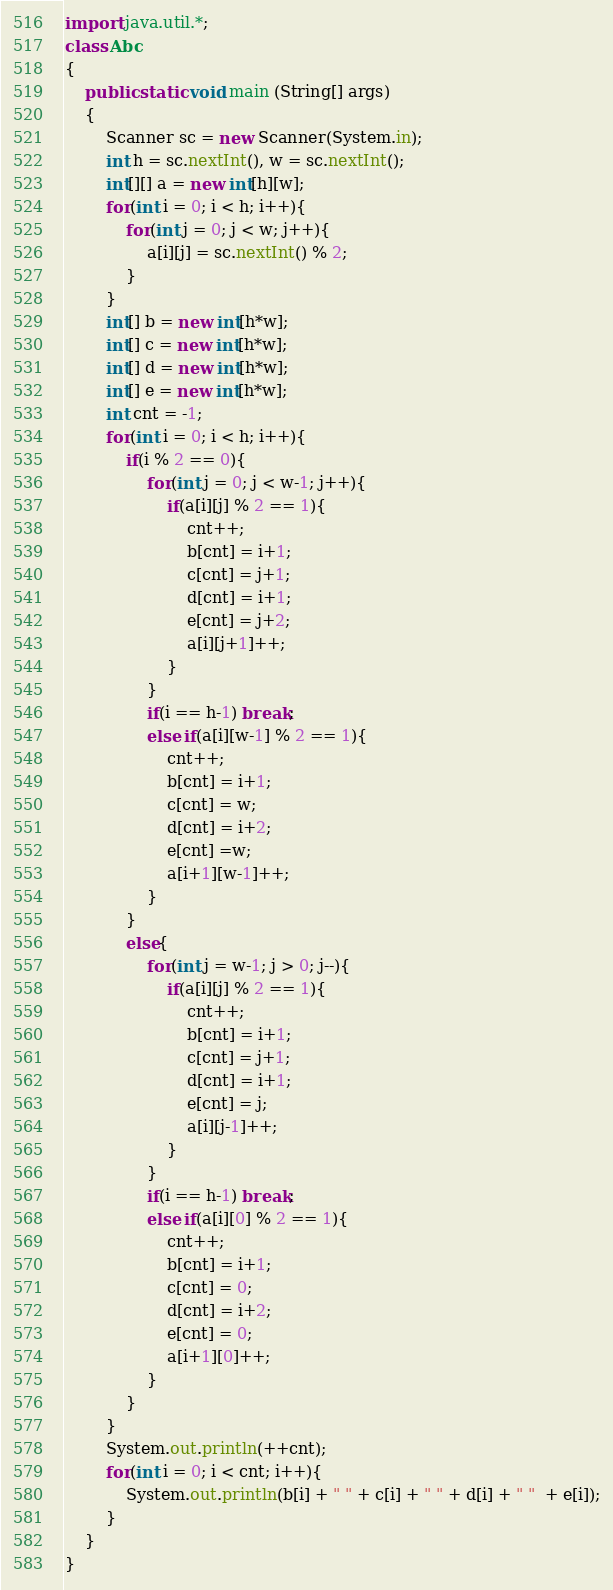Convert code to text. <code><loc_0><loc_0><loc_500><loc_500><_Java_>import java.util.*;
class Abc
{
    public static void main (String[] args)
    {
        Scanner sc = new Scanner(System.in);
        int h = sc.nextInt(), w = sc.nextInt();
        int[][] a = new int[h][w];
        for(int i = 0; i < h; i++){
            for(int j = 0; j < w; j++){
                a[i][j] = sc.nextInt() % 2;
            }
        }
        int[] b = new int[h*w];
        int[] c = new int[h*w];
        int[] d = new int[h*w];
        int[] e = new int[h*w];
        int cnt = -1;
        for(int i = 0; i < h; i++){
            if(i % 2 == 0){
                for(int j = 0; j < w-1; j++){
                    if(a[i][j] % 2 == 1){
                        cnt++;
                        b[cnt] = i+1;
                        c[cnt] = j+1;
                        d[cnt] = i+1;
                        e[cnt] = j+2;
                        a[i][j+1]++;
                    }
                }
                if(i == h-1) break;
                else if(a[i][w-1] % 2 == 1){
                    cnt++;
                    b[cnt] = i+1;
                    c[cnt] = w;
                    d[cnt] = i+2;
                    e[cnt] =w;
                    a[i+1][w-1]++;
                }
            }
            else{
                for(int j = w-1; j > 0; j--){
                    if(a[i][j] % 2 == 1){
                        cnt++;
                        b[cnt] = i+1;
                        c[cnt] = j+1;
                        d[cnt] = i+1;
                        e[cnt] = j;
                        a[i][j-1]++;
                    }
                }
                if(i == h-1) break;
                else if(a[i][0] % 2 == 1){
                    cnt++;
                    b[cnt] = i+1;
                    c[cnt] = 0;
                    d[cnt] = i+2;
                    e[cnt] = 0; 
                    a[i+1][0]++;
                }
            }
        }
        System.out.println(++cnt);
        for(int i = 0; i < cnt; i++){
            System.out.println(b[i] + " " + c[i] + " " + d[i] + " "  + e[i]);
        }
    }
}</code> 